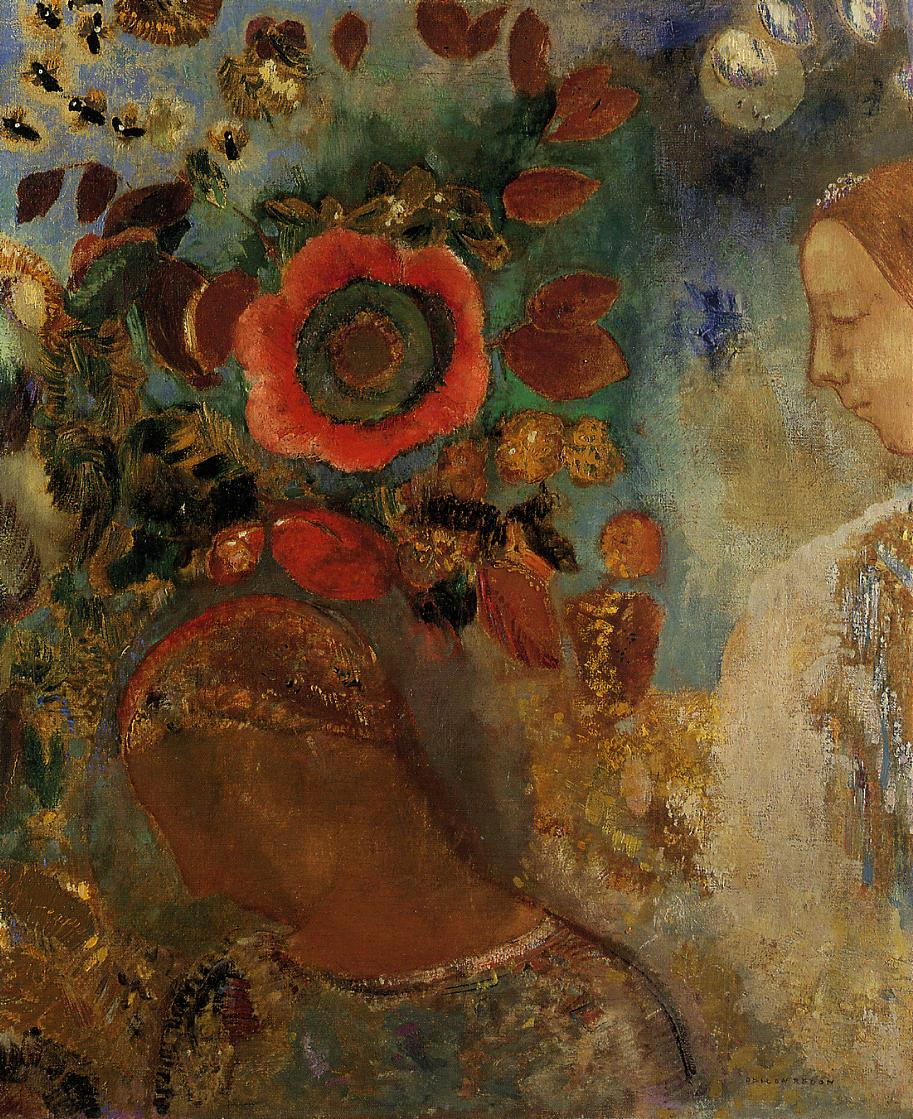Describe the surrounding environment in more detail. The background of the painting is a richly detailed and vibrant floral arrangement, characterized by a large, radiant red flower that stands out prominently. Surrounding this central bloom are various other flowers and foliage, depicted in a mix of warm yellows, oranges, and cool greens and blues. The brushstrokes used are dynamic and fluid, creating a sense of movement and depth within the composition. Closer inspection reveals subtle variations in color and texture, indicating an impressionistic approach where the focus is on capturing the overall atmosphere and emotional impact rather than precise details. The leaves and petals appear to be in a state of gentle motion, contributing to the lively yet tranquil ambiance of the scene. 